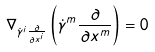Convert formula to latex. <formula><loc_0><loc_0><loc_500><loc_500>\nabla _ { { \dot { \gamma } } ^ { i } { \frac { \partial } { \partial x ^ { i } } } } \left ( { \dot { \gamma } } ^ { m } { \frac { \partial } { \partial x ^ { m } } } \right ) = 0</formula> 